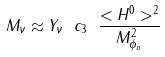Convert formula to latex. <formula><loc_0><loc_0><loc_500><loc_500>M _ { \nu } \approx Y _ { \nu } \ c _ { 3 } \ \frac { < H ^ { 0 } > ^ { 2 } } { M _ { \phi _ { a } } ^ { 2 } }</formula> 